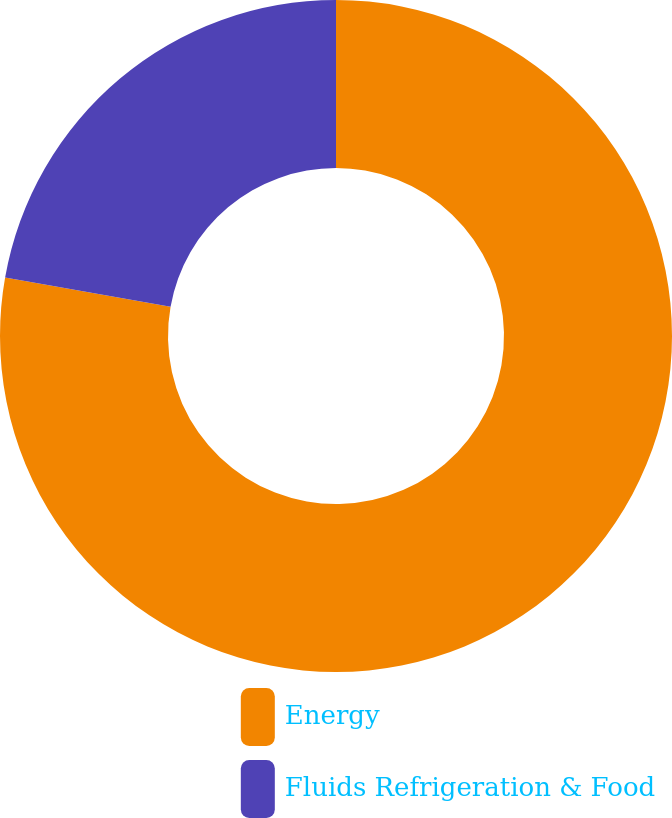Convert chart. <chart><loc_0><loc_0><loc_500><loc_500><pie_chart><fcel>Energy<fcel>Fluids Refrigeration & Food<nl><fcel>77.78%<fcel>22.22%<nl></chart> 